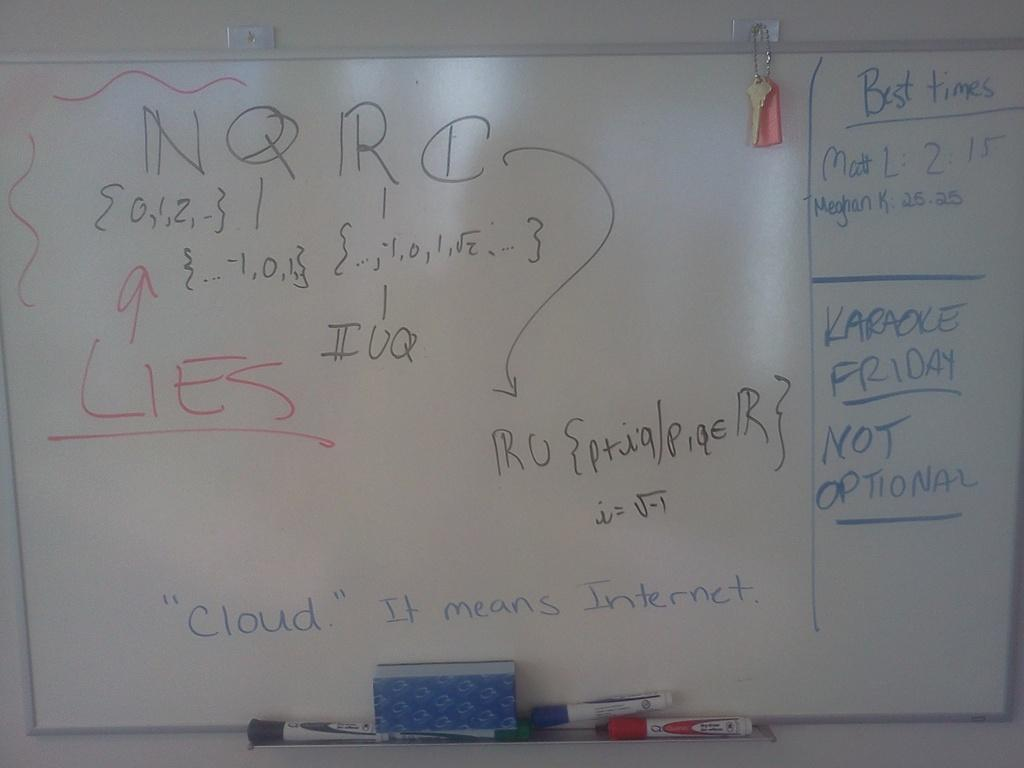Provide a one-sentence caption for the provided image. The best time shown for Matt L is 2.15. 